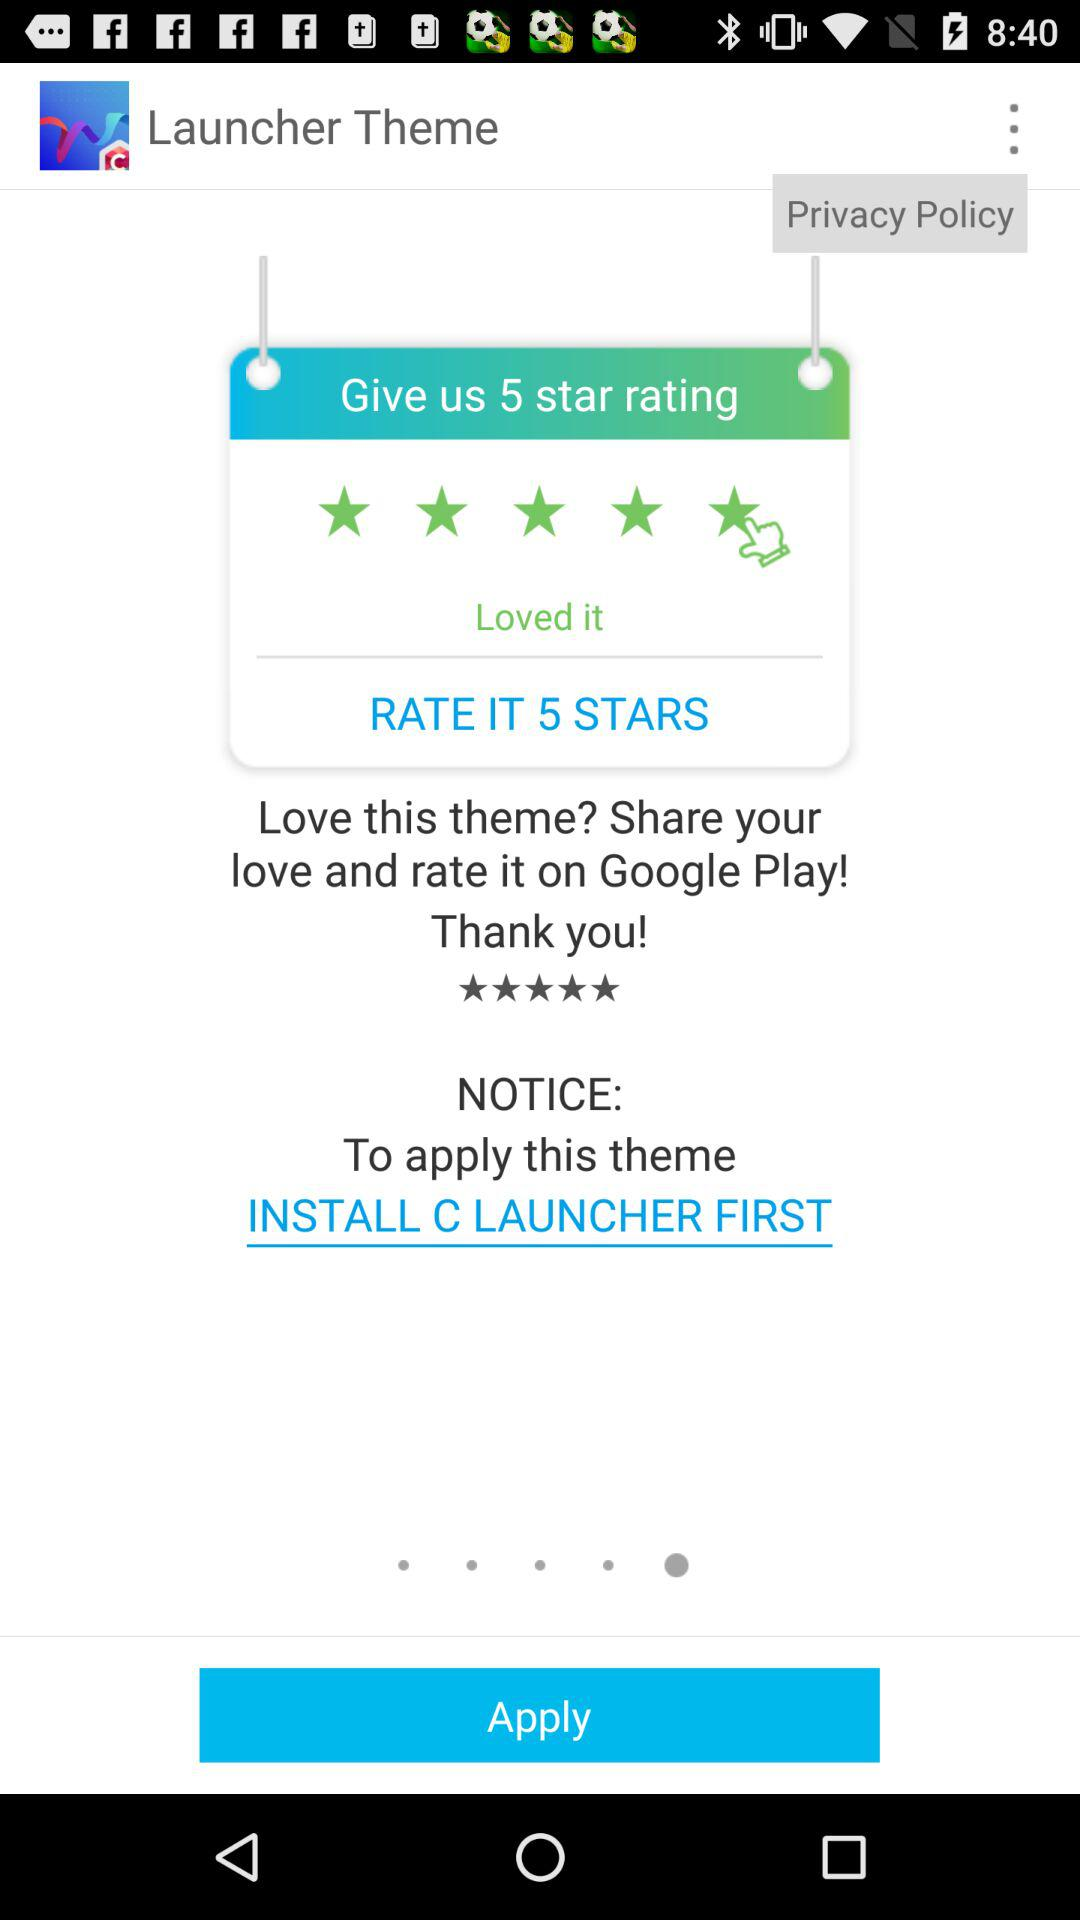What is the name of the application? The names of the applications are "Launcher Theme" and "C LAUNCHER". 